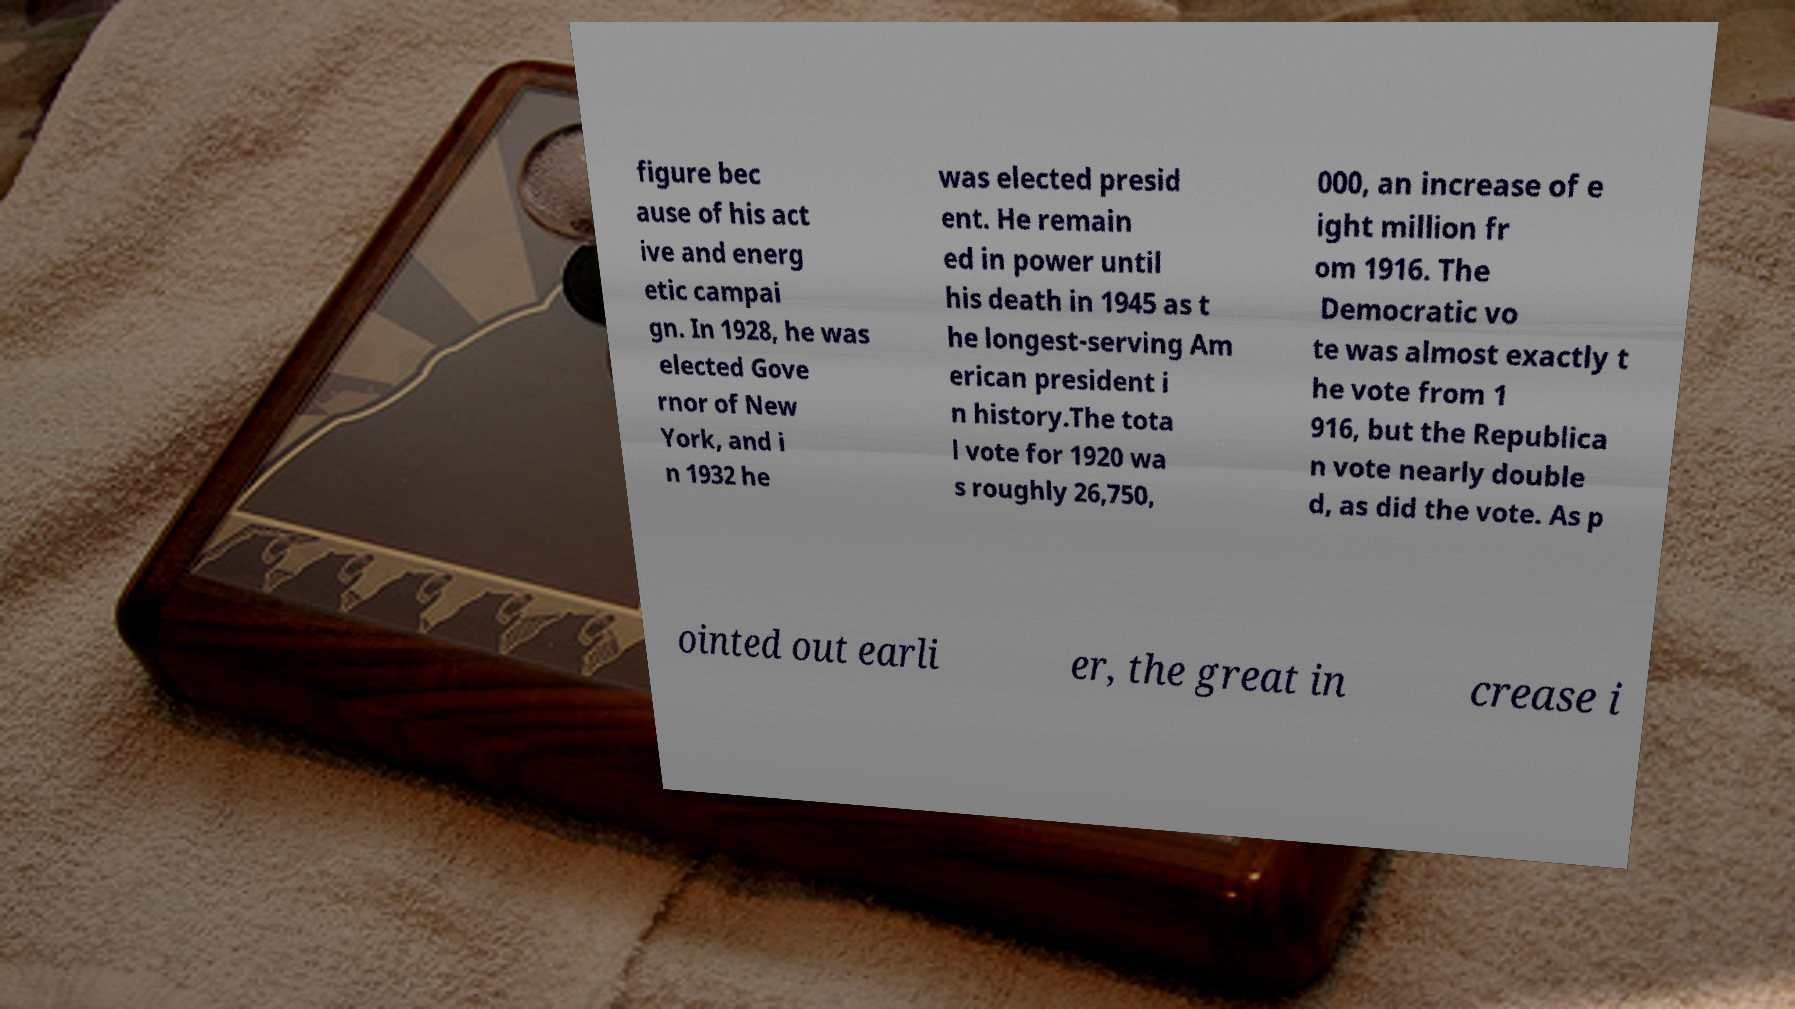Could you assist in decoding the text presented in this image and type it out clearly? figure bec ause of his act ive and energ etic campai gn. In 1928, he was elected Gove rnor of New York, and i n 1932 he was elected presid ent. He remain ed in power until his death in 1945 as t he longest-serving Am erican president i n history.The tota l vote for 1920 wa s roughly 26,750, 000, an increase of e ight million fr om 1916. The Democratic vo te was almost exactly t he vote from 1 916, but the Republica n vote nearly double d, as did the vote. As p ointed out earli er, the great in crease i 